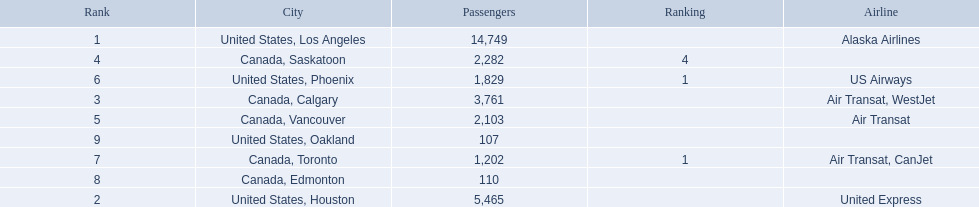What are the cities flown to? United States, Los Angeles, United States, Houston, Canada, Calgary, Canada, Saskatoon, Canada, Vancouver, United States, Phoenix, Canada, Toronto, Canada, Edmonton, United States, Oakland. What number of passengers did pheonix have? 1,829. 